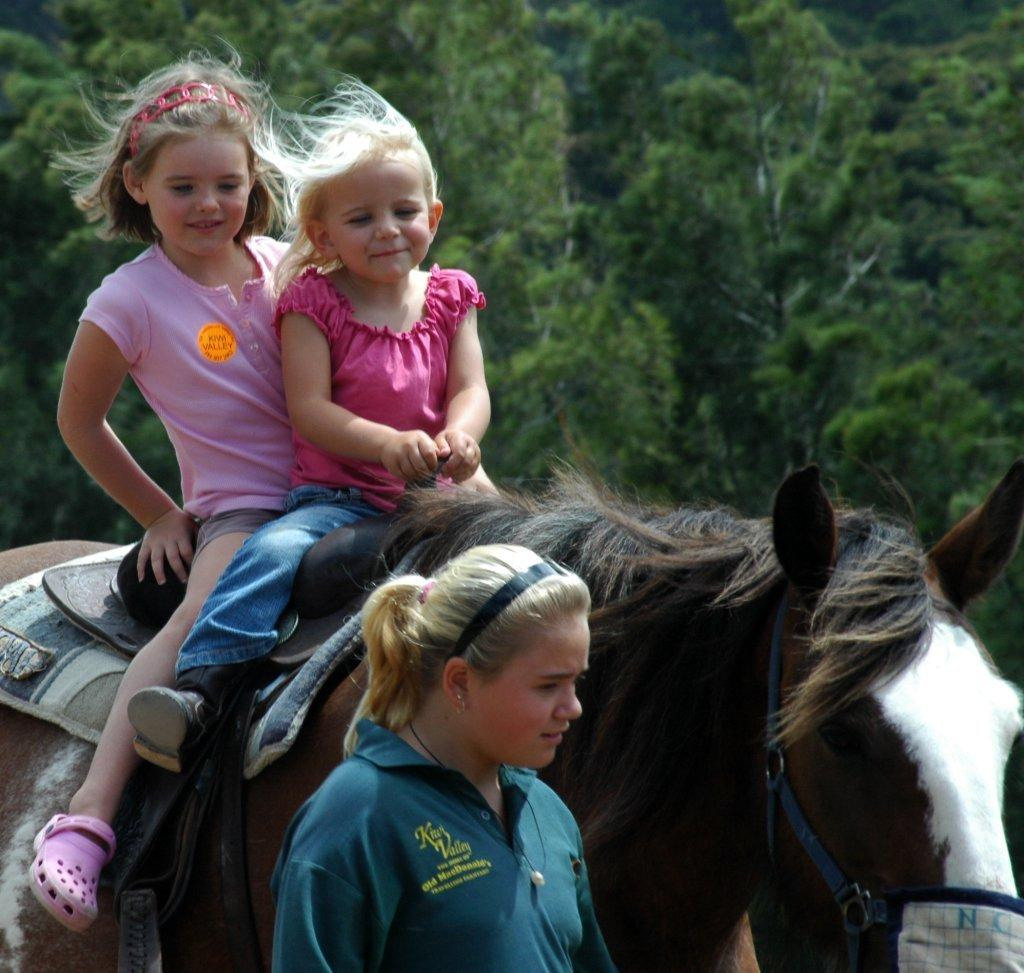What is the main subject in the image? There is a woman standing in the image. What are the two girls doing in the image? The two girls are sitting on a horse. Can you describe the horse in the image? The horse has a belt and is covered with small pieces of cloth. What can be seen in the background of the image? There are trees visible in the background of the image. What type of note is the woman holding in the image? There is no note visible in the image; the woman is simply standing. Is the horse in the image covered with snow or cherries? The horse is not covered with snow or cherries; it is covered with small pieces of cloth. 